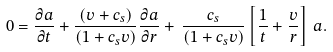Convert formula to latex. <formula><loc_0><loc_0><loc_500><loc_500>0 = \frac { \partial a } { \partial t } + \frac { \left ( v + c _ { s } \right ) } { \left ( 1 + c _ { s } v \right ) } \frac { \partial a } { \partial r } + \, \frac { c _ { s } } { \left ( 1 + c _ { s } v \right ) } \left [ \frac { 1 } { t } + \frac { v } { r } \right ] \, a .</formula> 